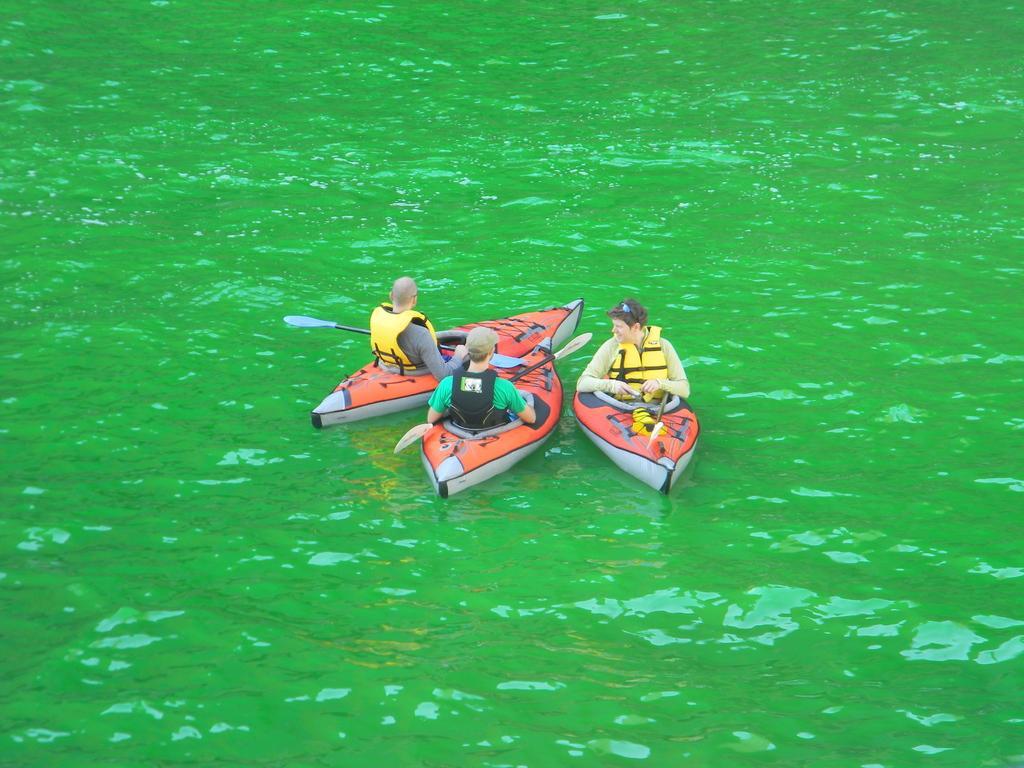Please provide a concise description of this image. In this image I can see three boats on the water. I can also see three persons on the boat and I can see all of them are holding paddles. I can see all of them are wearing life jackets and I can also see one person is wearing a cap. 